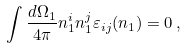<formula> <loc_0><loc_0><loc_500><loc_500>\int \frac { d \Omega _ { 1 } } { 4 \pi } n _ { 1 } ^ { i } n _ { 1 } ^ { j } \varepsilon _ { i j } ( { n } _ { 1 } ) = 0 \, ,</formula> 